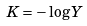Convert formula to latex. <formula><loc_0><loc_0><loc_500><loc_500>K = - \log Y</formula> 